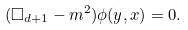Convert formula to latex. <formula><loc_0><loc_0><loc_500><loc_500>( \Box _ { d + 1 } - m ^ { 2 } ) \phi ( y , x ) = 0 .</formula> 